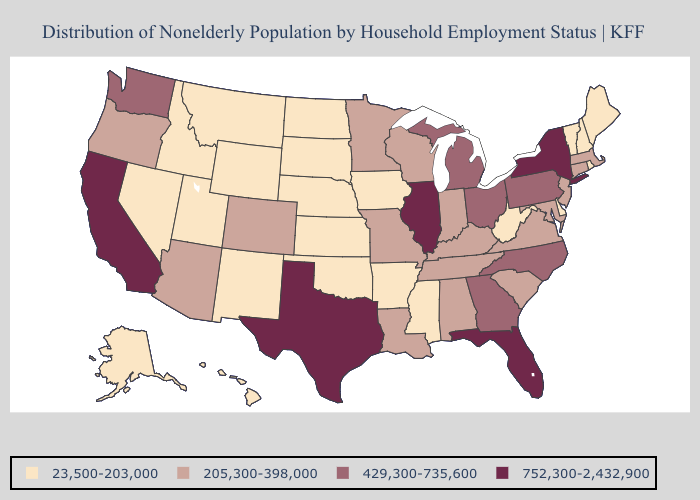How many symbols are there in the legend?
Quick response, please. 4. What is the highest value in the South ?
Be succinct. 752,300-2,432,900. What is the highest value in states that border Vermont?
Short answer required. 752,300-2,432,900. Does Hawaii have a lower value than Kentucky?
Give a very brief answer. Yes. Does Texas have the highest value in the South?
Answer briefly. Yes. Name the states that have a value in the range 205,300-398,000?
Short answer required. Alabama, Arizona, Colorado, Connecticut, Indiana, Kentucky, Louisiana, Maryland, Massachusetts, Minnesota, Missouri, New Jersey, Oregon, South Carolina, Tennessee, Virginia, Wisconsin. What is the value of Minnesota?
Short answer required. 205,300-398,000. Name the states that have a value in the range 752,300-2,432,900?
Short answer required. California, Florida, Illinois, New York, Texas. What is the lowest value in the USA?
Short answer required. 23,500-203,000. What is the highest value in the USA?
Short answer required. 752,300-2,432,900. Name the states that have a value in the range 429,300-735,600?
Keep it brief. Georgia, Michigan, North Carolina, Ohio, Pennsylvania, Washington. What is the value of Georgia?
Write a very short answer. 429,300-735,600. What is the value of Colorado?
Quick response, please. 205,300-398,000. What is the lowest value in the MidWest?
Keep it brief. 23,500-203,000. Name the states that have a value in the range 23,500-203,000?
Concise answer only. Alaska, Arkansas, Delaware, Hawaii, Idaho, Iowa, Kansas, Maine, Mississippi, Montana, Nebraska, Nevada, New Hampshire, New Mexico, North Dakota, Oklahoma, Rhode Island, South Dakota, Utah, Vermont, West Virginia, Wyoming. 